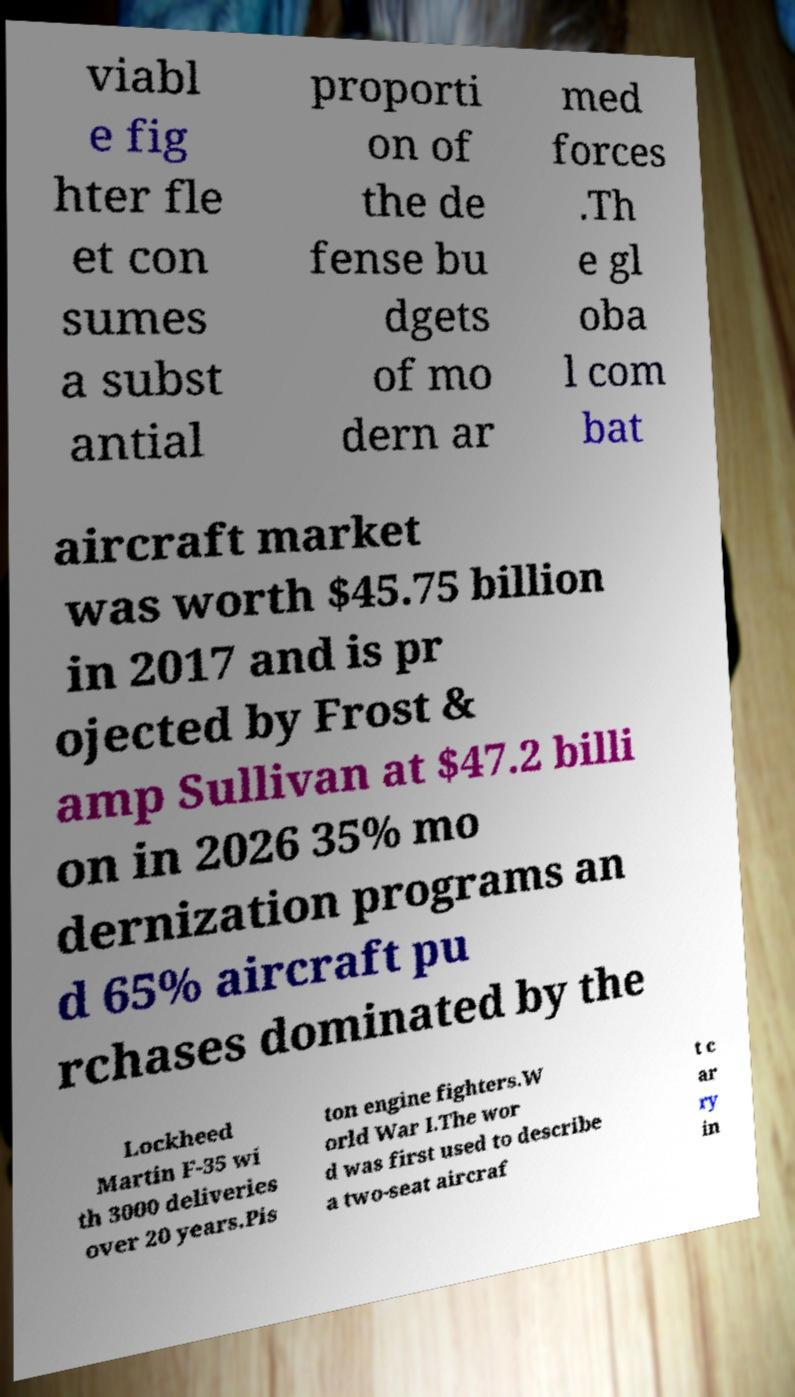I need the written content from this picture converted into text. Can you do that? viabl e fig hter fle et con sumes a subst antial proporti on of the de fense bu dgets of mo dern ar med forces .Th e gl oba l com bat aircraft market was worth $45.75 billion in 2017 and is pr ojected by Frost & amp Sullivan at $47.2 billi on in 2026 35% mo dernization programs an d 65% aircraft pu rchases dominated by the Lockheed Martin F-35 wi th 3000 deliveries over 20 years.Pis ton engine fighters.W orld War I.The wor d was first used to describe a two-seat aircraf t c ar ry in 